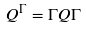<formula> <loc_0><loc_0><loc_500><loc_500>Q ^ { \Gamma } = \Gamma Q \Gamma</formula> 